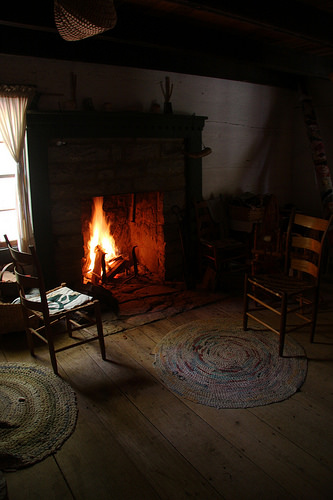<image>
Is there a fire behind the chair? Yes. From this viewpoint, the fire is positioned behind the chair, with the chair partially or fully occluding the fire. Is there a chair next to the chair? No. The chair is not positioned next to the chair. They are located in different areas of the scene. 